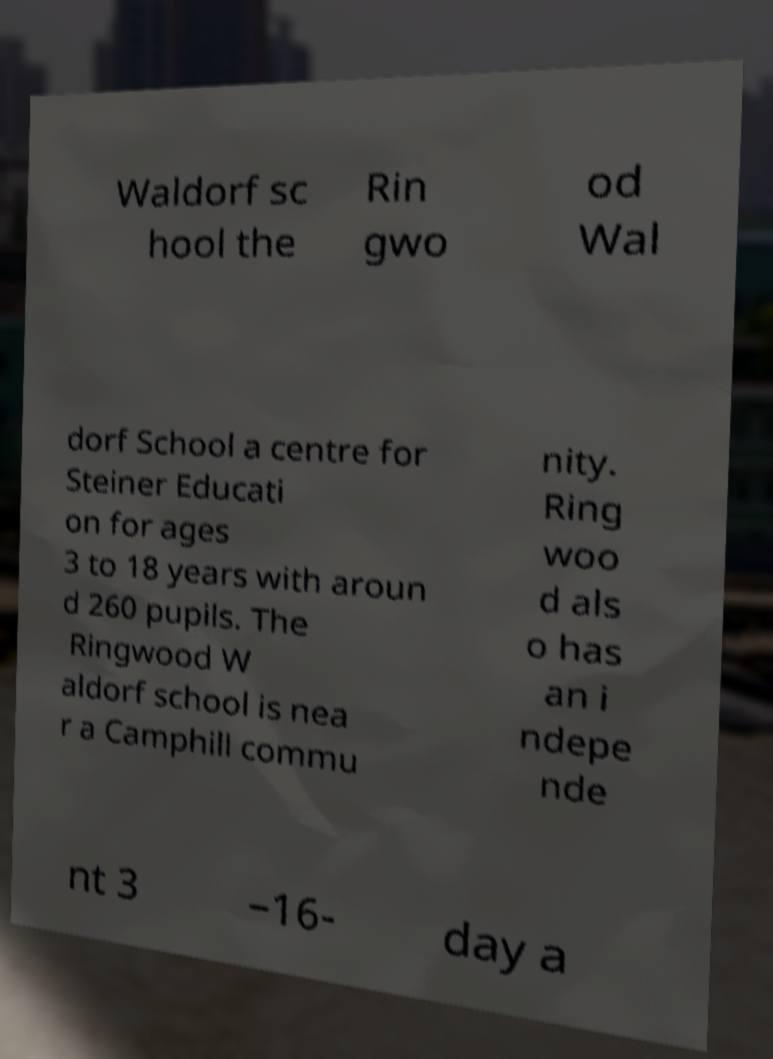There's text embedded in this image that I need extracted. Can you transcribe it verbatim? Waldorf sc hool the Rin gwo od Wal dorf School a centre for Steiner Educati on for ages 3 to 18 years with aroun d 260 pupils. The Ringwood W aldorf school is nea r a Camphill commu nity. Ring woo d als o has an i ndepe nde nt 3 –16- day a 